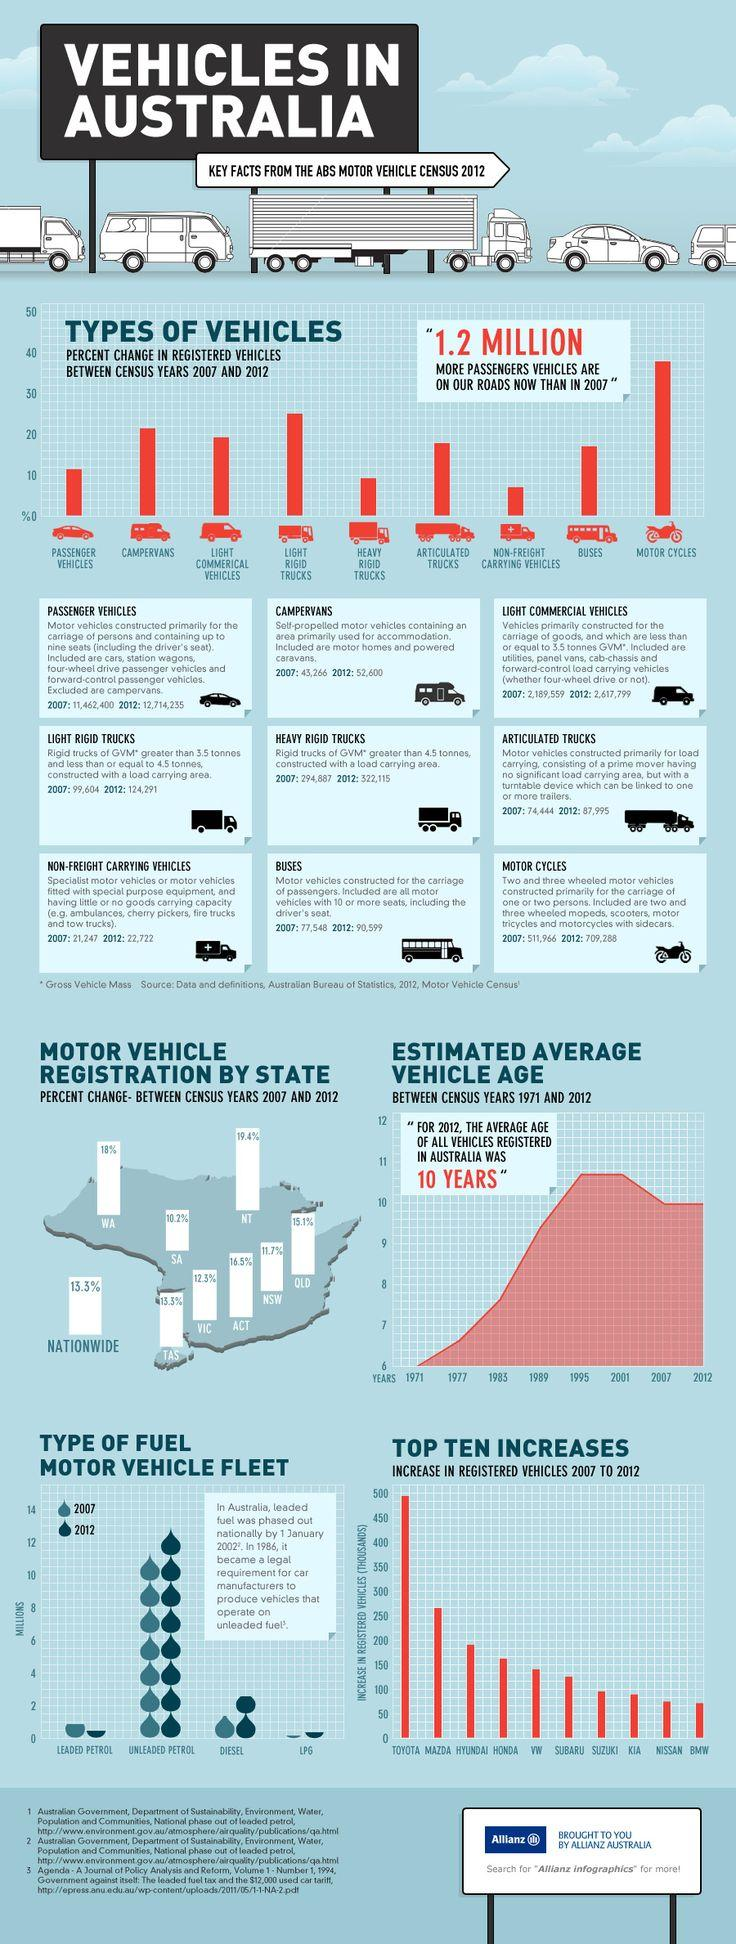Specify some key components in this picture. The passenger vehicles experienced a 10% increase in percent change. From 2007 to 2012, the number of motorcycles has increased. Nine vehicles have been considered for the study. 